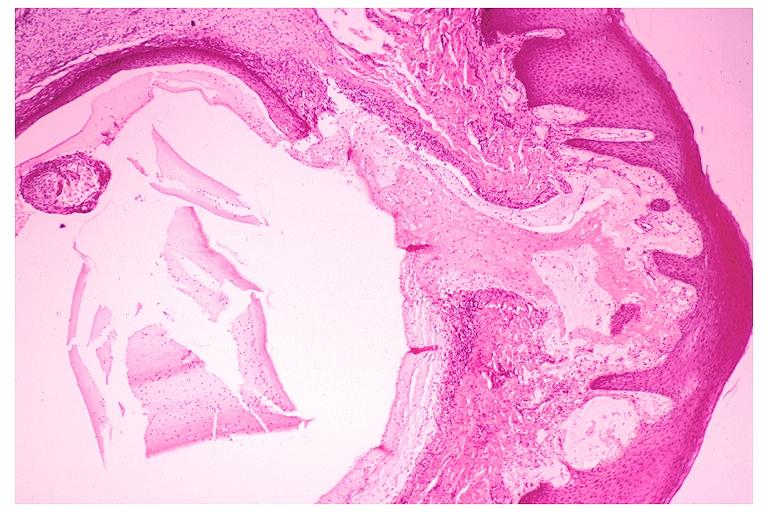s lip present?
Answer the question using a single word or phrase. No 